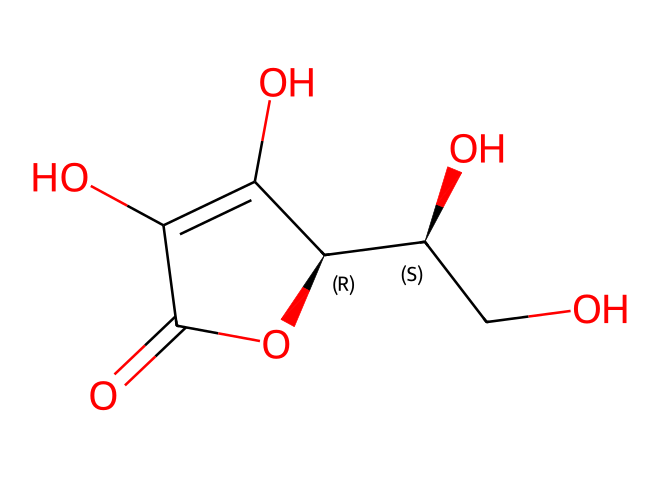What is the molecular formula of ascorbic acid? To determine the molecular formula, we can count the number of each type of atom in the SMILES representation. From the structure, we find 6 carbon (C) atoms, 8 hydrogen (H) atoms, and 6 oxygen (O) atoms. Thus, the molecular formula is C6H8O6.
Answer: C6H8O6 How many chiral centers are present in ascorbic acid? A chiral center is typically a carbon atom that is attached to four different groups. By examining the structure in the SMILES, we identify two carbon atoms that are connected to four distinct substituents, making the total two chiral centers.
Answer: 2 What type of functional groups are found in ascorbic acid? The structure contains several functional groups including hydroxyl groups (-OH), a carbonyl group (C=O), and an additional carbonyl-type functionality as part of a lactone ring. Thus, it has both hydroxyl and carbonyl functional groups.
Answer: hydroxyl and carbonyl Is ascorbic acid a strong or weak acid? Ascorbic acid is classified as a weak acid because it does not fully dissociate in solution unlike strong acids. This can be inferred from its chemical structure, which contains only a few acidic hydrogen atoms.
Answer: weak What is the role of ascorbic acid in biological systems? Ascorbic acid serves as an essential vitamin (Vitamin C) that acts as an antioxidant, protecting cells from damage, and is also critical in synthesizing collagen and certain neurotransmitters. This function is aligned with its structural features that allow it to participate in redox reactions.
Answer: antioxidant What can be inferred about the solubility of ascorbic acid in water? Given the presence of multiple polar hydroxyl (-OH) groups and the overall structure, ascorbic acid is expected to be soluble in water due to hydrogen bonding capabilities. The high number of hydroxyl groups enhances its interaction with water.
Answer: soluble 